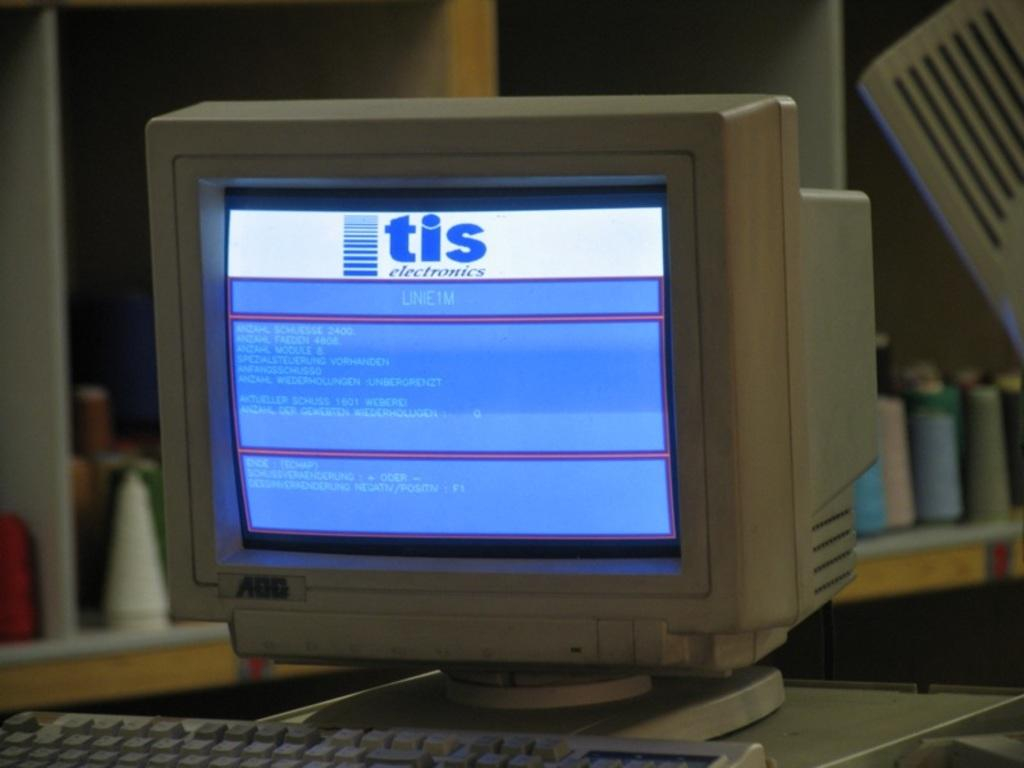<image>
Describe the image concisely. A computer that is on with a blue and white screen with the word tis at top 